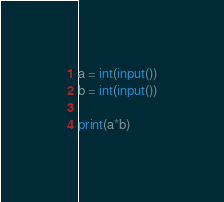<code> <loc_0><loc_0><loc_500><loc_500><_Python_>a = int(input())
b = int(input())

print(a*b)</code> 